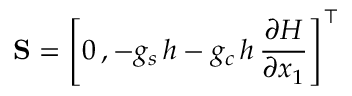Convert formula to latex. <formula><loc_0><loc_0><loc_500><loc_500>{ S } = \left [ 0 \, , - g _ { s } \, { h } - g _ { c } \, { h } \, \frac { \partial { H } } { \partial { x } _ { 1 } } \right ] ^ { \top }</formula> 